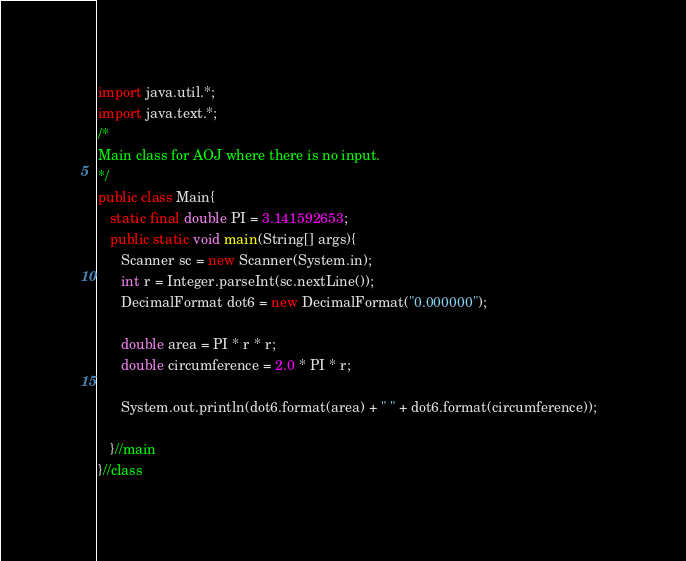Convert code to text. <code><loc_0><loc_0><loc_500><loc_500><_Java_>import java.util.*;
import java.text.*;
/*
Main class for AOJ where there is no input.
*/
public class Main{
   static final double PI = 3.141592653;
   public static void main(String[] args){
      Scanner sc = new Scanner(System.in);
      int r = Integer.parseInt(sc.nextLine());
      DecimalFormat dot6 = new DecimalFormat("0.000000");
      
      double area = PI * r * r;
      double circumference = 2.0 * PI * r;
      
      System.out.println(dot6.format(area) + " " + dot6.format(circumference));  
      
   }//main
}//class</code> 